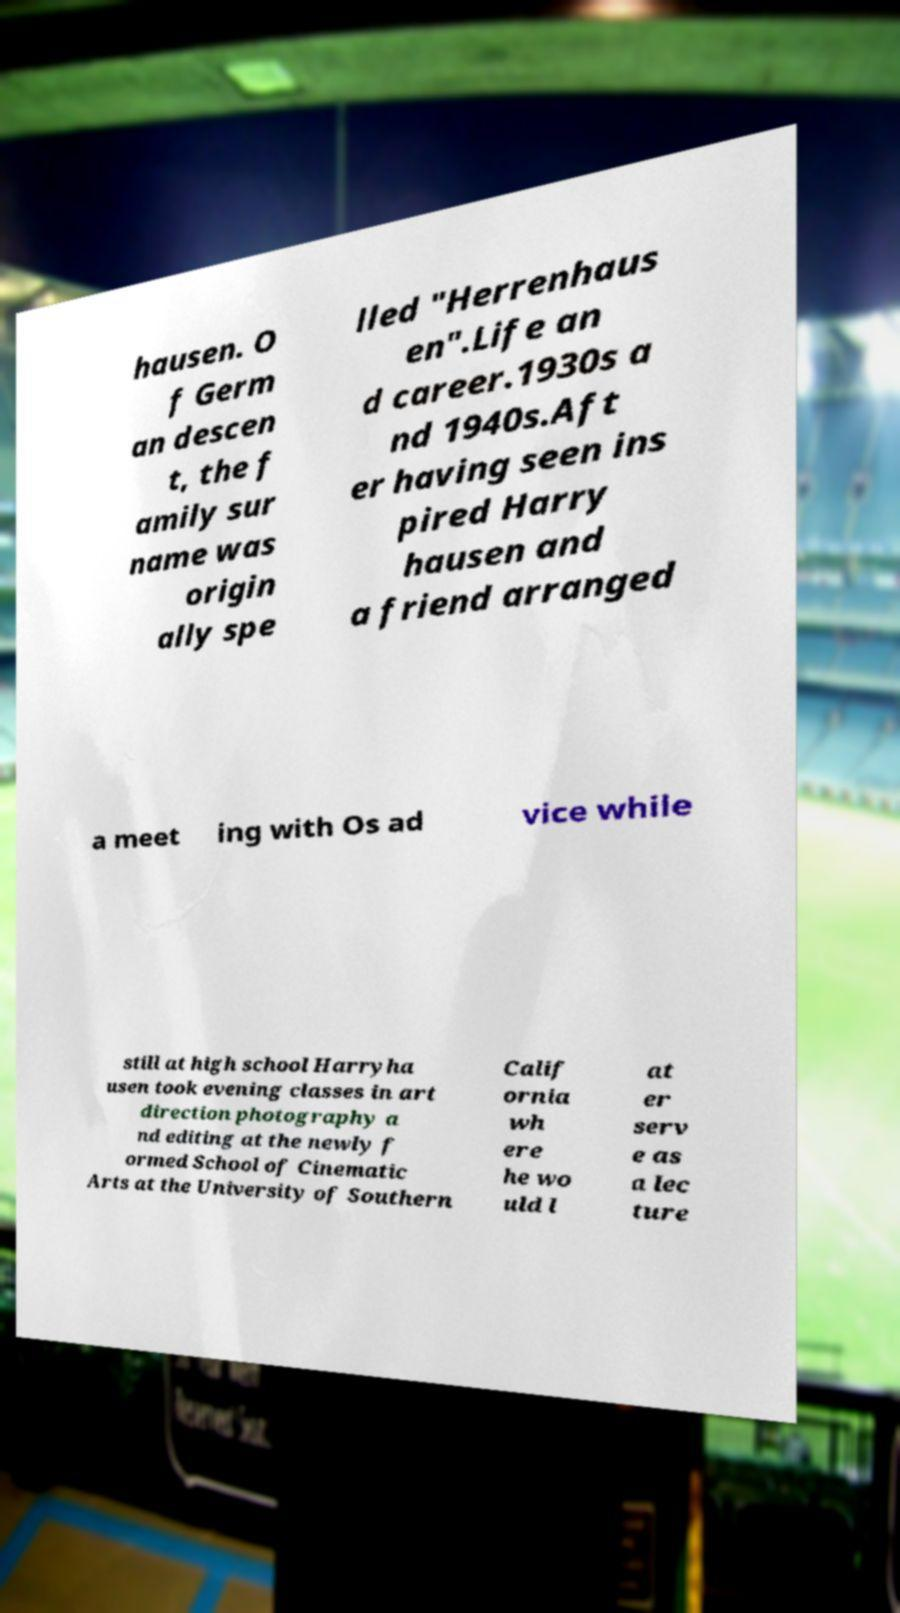Could you assist in decoding the text presented in this image and type it out clearly? hausen. O f Germ an descen t, the f amily sur name was origin ally spe lled "Herrenhaus en".Life an d career.1930s a nd 1940s.Aft er having seen ins pired Harry hausen and a friend arranged a meet ing with Os ad vice while still at high school Harryha usen took evening classes in art direction photography a nd editing at the newly f ormed School of Cinematic Arts at the University of Southern Calif ornia wh ere he wo uld l at er serv e as a lec ture 